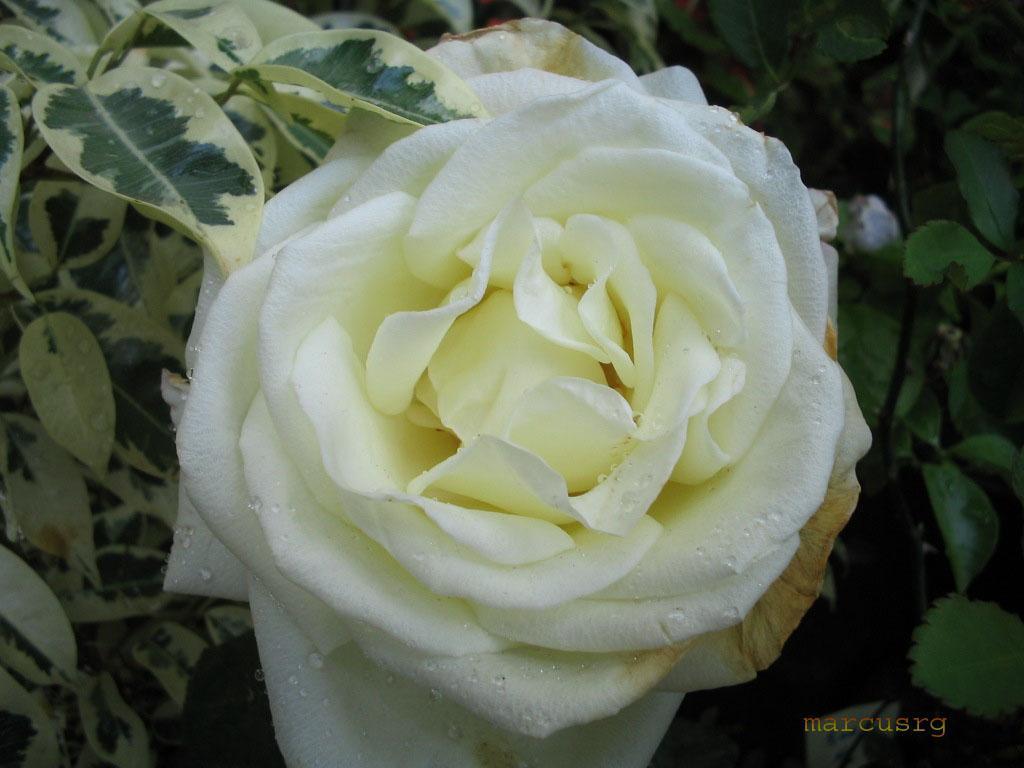In one or two sentences, can you explain what this image depicts? In this image I can see a flower which is yellow and white in color to a tree and I can see few leaves of a tree which are green and cream in color. 